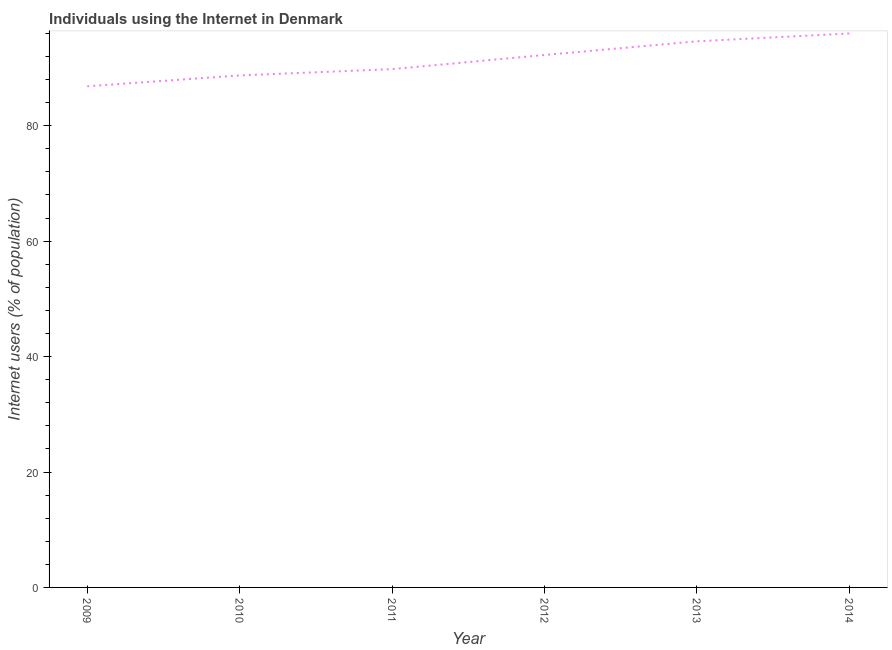What is the number of internet users in 2012?
Offer a very short reply. 92.26. Across all years, what is the maximum number of internet users?
Offer a very short reply. 95.99. Across all years, what is the minimum number of internet users?
Offer a terse response. 86.84. What is the sum of the number of internet users?
Make the answer very short. 548.25. What is the difference between the number of internet users in 2010 and 2014?
Provide a succinct answer. -7.27. What is the average number of internet users per year?
Keep it short and to the point. 91.37. What is the median number of internet users?
Ensure brevity in your answer.  91.04. What is the ratio of the number of internet users in 2010 to that in 2011?
Ensure brevity in your answer.  0.99. Is the number of internet users in 2010 less than that in 2011?
Offer a very short reply. Yes. Is the difference between the number of internet users in 2009 and 2010 greater than the difference between any two years?
Your response must be concise. No. What is the difference between the highest and the second highest number of internet users?
Provide a succinct answer. 1.36. What is the difference between the highest and the lowest number of internet users?
Your response must be concise. 9.15. Does the number of internet users monotonically increase over the years?
Provide a succinct answer. Yes. How many lines are there?
Offer a very short reply. 1. How many years are there in the graph?
Give a very brief answer. 6. Does the graph contain any zero values?
Give a very brief answer. No. What is the title of the graph?
Make the answer very short. Individuals using the Internet in Denmark. What is the label or title of the Y-axis?
Ensure brevity in your answer.  Internet users (% of population). What is the Internet users (% of population) in 2009?
Offer a very short reply. 86.84. What is the Internet users (% of population) in 2010?
Provide a succinct answer. 88.72. What is the Internet users (% of population) in 2011?
Keep it short and to the point. 89.81. What is the Internet users (% of population) of 2012?
Your answer should be very brief. 92.26. What is the Internet users (% of population) in 2013?
Give a very brief answer. 94.63. What is the Internet users (% of population) in 2014?
Keep it short and to the point. 95.99. What is the difference between the Internet users (% of population) in 2009 and 2010?
Your answer should be very brief. -1.88. What is the difference between the Internet users (% of population) in 2009 and 2011?
Provide a succinct answer. -2.97. What is the difference between the Internet users (% of population) in 2009 and 2012?
Provide a short and direct response. -5.42. What is the difference between the Internet users (% of population) in 2009 and 2013?
Keep it short and to the point. -7.79. What is the difference between the Internet users (% of population) in 2009 and 2014?
Make the answer very short. -9.15. What is the difference between the Internet users (% of population) in 2010 and 2011?
Offer a very short reply. -1.09. What is the difference between the Internet users (% of population) in 2010 and 2012?
Provide a short and direct response. -3.54. What is the difference between the Internet users (% of population) in 2010 and 2013?
Your answer should be compact. -5.91. What is the difference between the Internet users (% of population) in 2010 and 2014?
Offer a very short reply. -7.27. What is the difference between the Internet users (% of population) in 2011 and 2012?
Give a very brief answer. -2.45. What is the difference between the Internet users (% of population) in 2011 and 2013?
Your answer should be very brief. -4.82. What is the difference between the Internet users (% of population) in 2011 and 2014?
Make the answer very short. -6.18. What is the difference between the Internet users (% of population) in 2012 and 2013?
Ensure brevity in your answer.  -2.37. What is the difference between the Internet users (% of population) in 2012 and 2014?
Provide a succinct answer. -3.73. What is the difference between the Internet users (% of population) in 2013 and 2014?
Your answer should be very brief. -1.36. What is the ratio of the Internet users (% of population) in 2009 to that in 2010?
Ensure brevity in your answer.  0.98. What is the ratio of the Internet users (% of population) in 2009 to that in 2011?
Your answer should be compact. 0.97. What is the ratio of the Internet users (% of population) in 2009 to that in 2012?
Your response must be concise. 0.94. What is the ratio of the Internet users (% of population) in 2009 to that in 2013?
Keep it short and to the point. 0.92. What is the ratio of the Internet users (% of population) in 2009 to that in 2014?
Provide a succinct answer. 0.91. What is the ratio of the Internet users (% of population) in 2010 to that in 2011?
Ensure brevity in your answer.  0.99. What is the ratio of the Internet users (% of population) in 2010 to that in 2013?
Offer a very short reply. 0.94. What is the ratio of the Internet users (% of population) in 2010 to that in 2014?
Your answer should be very brief. 0.92. What is the ratio of the Internet users (% of population) in 2011 to that in 2013?
Your answer should be very brief. 0.95. What is the ratio of the Internet users (% of population) in 2011 to that in 2014?
Your response must be concise. 0.94. What is the ratio of the Internet users (% of population) in 2012 to that in 2014?
Your response must be concise. 0.96. What is the ratio of the Internet users (% of population) in 2013 to that in 2014?
Ensure brevity in your answer.  0.99. 